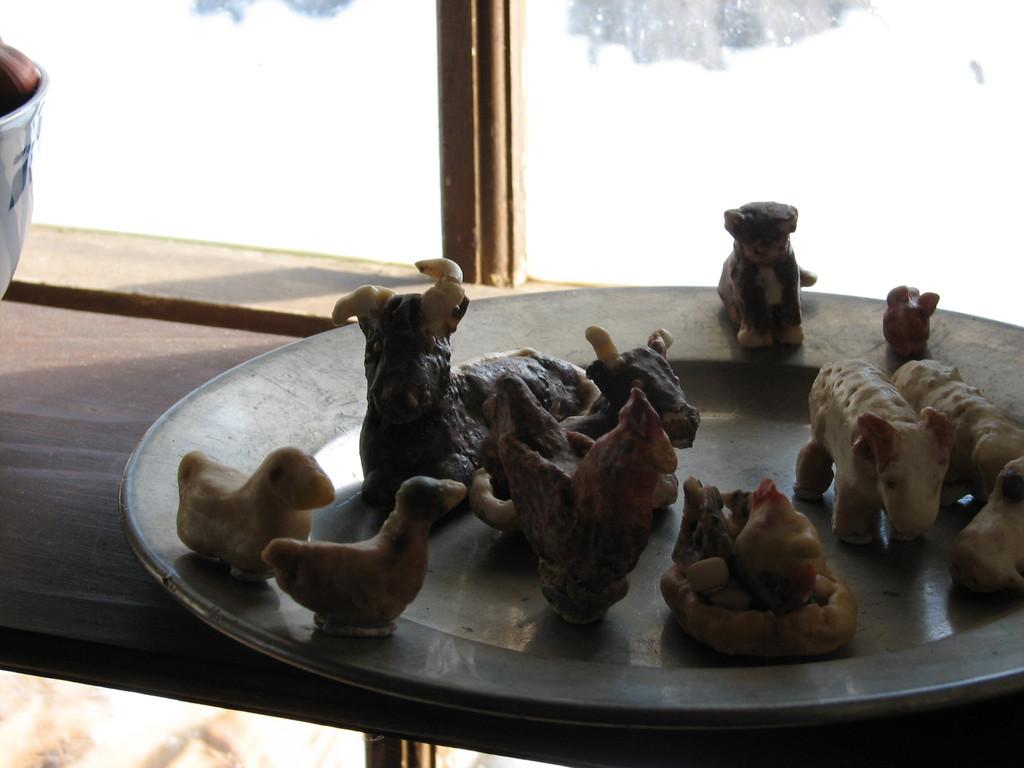What is on the plate in the image? There is a plate with animal toys in the image. What is the plate placed on? The plate is on a wooden object. What can be seen in the background of the image? There is a transparent glass in the background of the image. What type of love is depicted in the image? There is no depiction of love in the image; it features a plate with animal toys and a wooden object. What type of ornament is present on the wooden object? There is no ornament present on the wooden object; it is simply a wooden surface for the plate. 